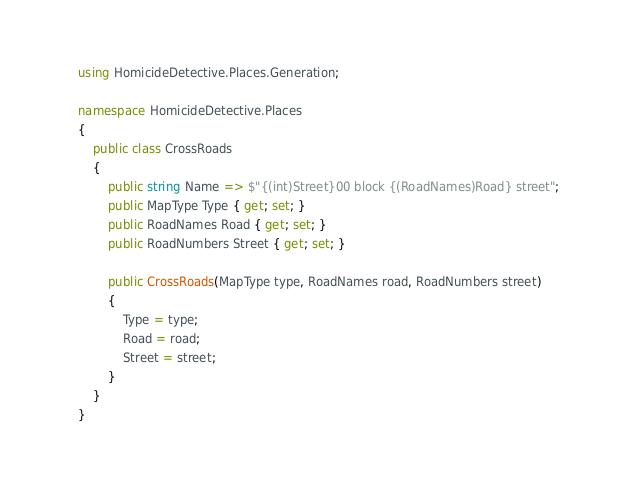Convert code to text. <code><loc_0><loc_0><loc_500><loc_500><_C#_>using HomicideDetective.Places.Generation;

namespace HomicideDetective.Places
{
    public class CrossRoads
    {
        public string Name => $"{(int)Street}00 block {(RoadNames)Road} street";
        public MapType Type { get; set; }
        public RoadNames Road { get; set; }
        public RoadNumbers Street { get; set; }
        
        public CrossRoads(MapType type, RoadNames road, RoadNumbers street)
        {
            Type = type;
            Road = road;
            Street = street;
        }
    }
}</code> 